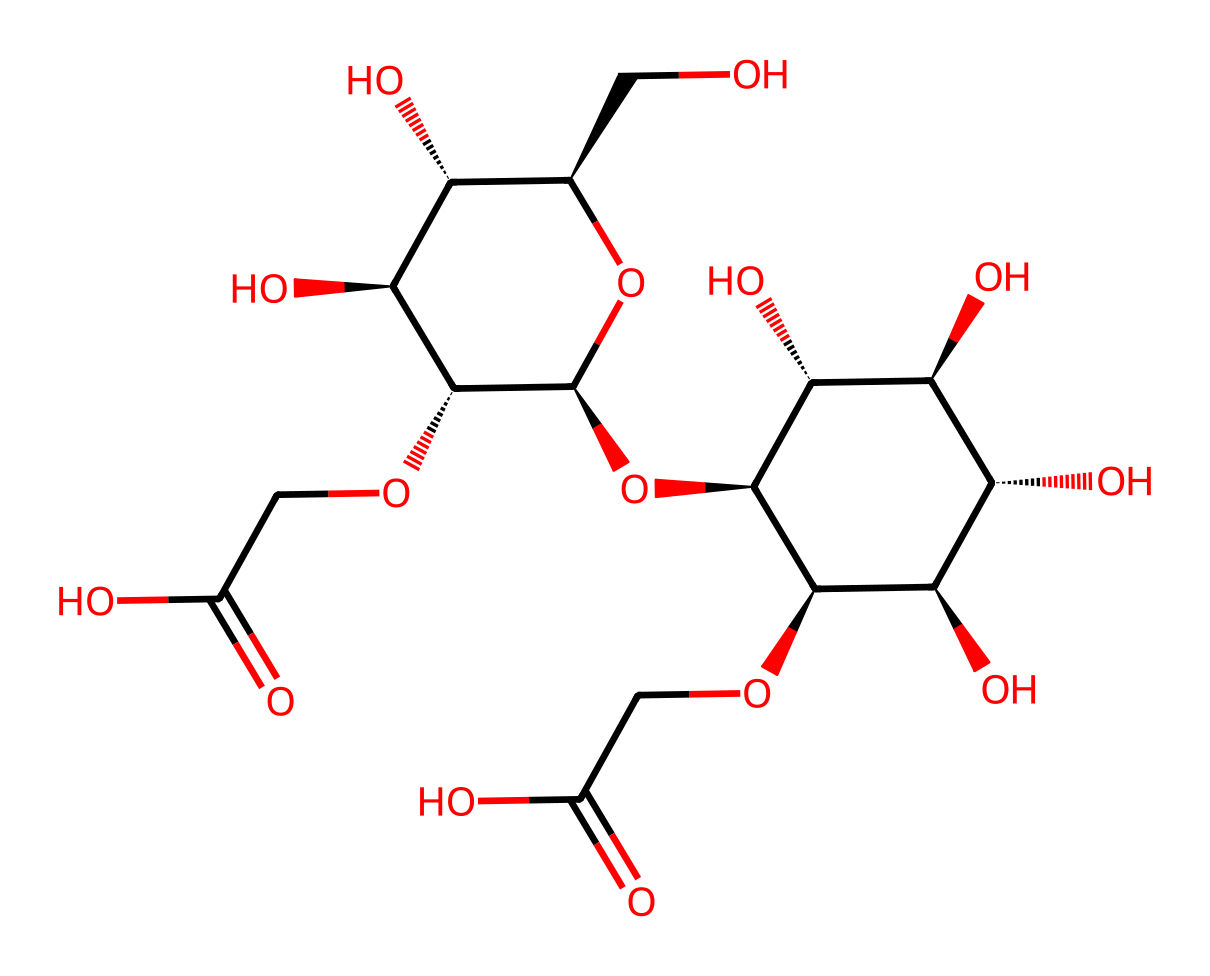What is the primary structural component of this chemical? The structure displays multiple hydroxyl (OH) groups attached to a carbohydrate backbone, indicating that carboxymethyl cellulose is the primary component.
Answer: carboxymethyl cellulose How many hydroxyl groups are in the structure? By visually counting the -OH groups in the rendered chemical, there are several identified. Specifically, there are 8 hydroxyl groups present in the structure.
Answer: 8 What is the significance of the carboxymethyl groups in this chemical? The carboxymethyl groups make the polymer soluble in water, giving it properties suited for creating non-Newtonian fluids like fake blood.
Answer: solubility Is this chemical an example of a polymer? The presence of repeating units in the structure, characteristic of large molecules, confirms this is indeed a polymer.
Answer: yes Which property enables this chemical to be classified as a Non-Newtonian fluid? The presence of the carboxymethyl groups allows it to change viscosity under stress, a key feature of Non-Newtonian fluids.
Answer: viscosity change What type of reaction can produce the carboxymethyl cellulose used in fake blood? The process involves the reaction of cellulose with chloroacetic acid to form carboxymethyl cellulose, indicating an esterification reaction.
Answer: esterification 